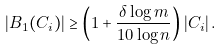Convert formula to latex. <formula><loc_0><loc_0><loc_500><loc_500>| B _ { 1 } ( C _ { i } ) | \geq \left ( 1 + \frac { \delta \log m } { 1 0 \log n } \right ) | C _ { i } | \, .</formula> 